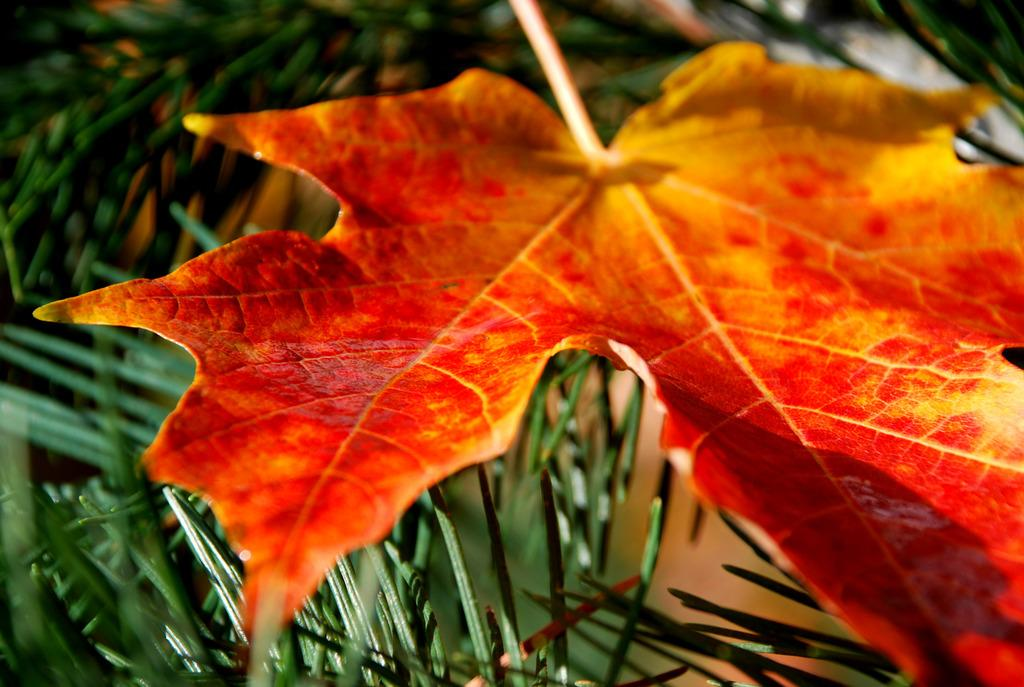What is the main subject of the image? The main subject of the image is a leaf. What type of potato is shown being crushed in the image? There is no potato present in the image, and no action of crushing is depicted. 